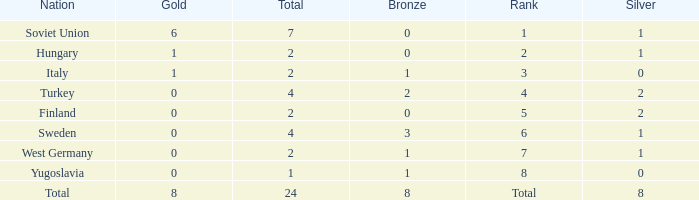Can you give me this table as a dict? {'header': ['Nation', 'Gold', 'Total', 'Bronze', 'Rank', 'Silver'], 'rows': [['Soviet Union', '6', '7', '0', '1', '1'], ['Hungary', '1', '2', '0', '2', '1'], ['Italy', '1', '2', '1', '3', '0'], ['Turkey', '0', '4', '2', '4', '2'], ['Finland', '0', '2', '0', '5', '2'], ['Sweden', '0', '4', '3', '6', '1'], ['West Germany', '0', '2', '1', '7', '1'], ['Yugoslavia', '0', '1', '1', '8', '0'], ['Total', '8', '24', '8', 'Total', '8']]} What is the highest Total, when Gold is 1, when Nation is Hungary, and when Bronze is less than 0? None. 